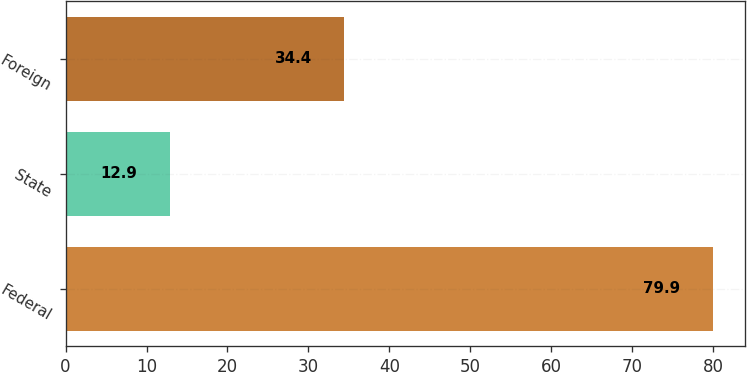<chart> <loc_0><loc_0><loc_500><loc_500><bar_chart><fcel>Federal<fcel>State<fcel>Foreign<nl><fcel>79.9<fcel>12.9<fcel>34.4<nl></chart> 